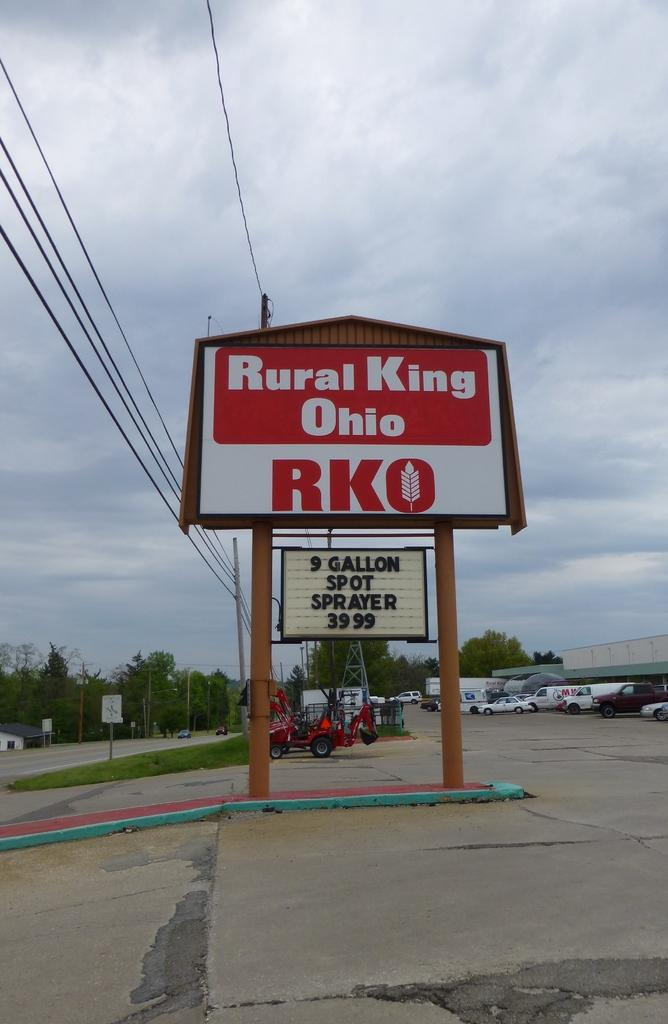<image>
Give a short and clear explanation of the subsequent image. A sign outside saying Rural King Ohio RKO and a 9 Gallon Spot Sprayer for $39.99, 